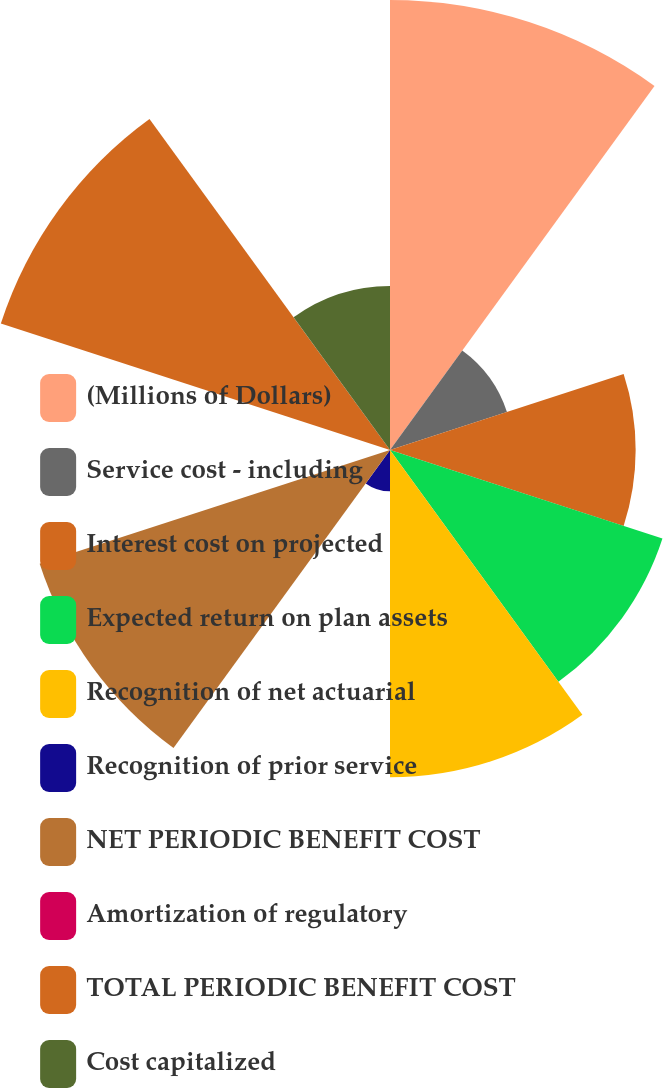<chart> <loc_0><loc_0><loc_500><loc_500><pie_chart><fcel>(Millions of Dollars)<fcel>Service cost - including<fcel>Interest cost on projected<fcel>Expected return on plan assets<fcel>Recognition of net actuarial<fcel>Recognition of prior service<fcel>NET PERIODIC BENEFIT COST<fcel>Amortization of regulatory<fcel>TOTAL PERIODIC BENEFIT COST<fcel>Cost capitalized<nl><fcel>18.63%<fcel>5.09%<fcel>10.17%<fcel>11.86%<fcel>13.55%<fcel>1.71%<fcel>15.25%<fcel>0.02%<fcel>16.94%<fcel>6.79%<nl></chart> 